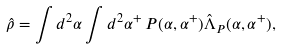Convert formula to latex. <formula><loc_0><loc_0><loc_500><loc_500>\hat { \rho } = \int d ^ { 2 } \alpha \int d ^ { 2 } \alpha ^ { + } \, P ( \alpha , \alpha ^ { + } ) \hat { \Lambda } _ { P } ( \alpha , \alpha ^ { + } ) ,</formula> 